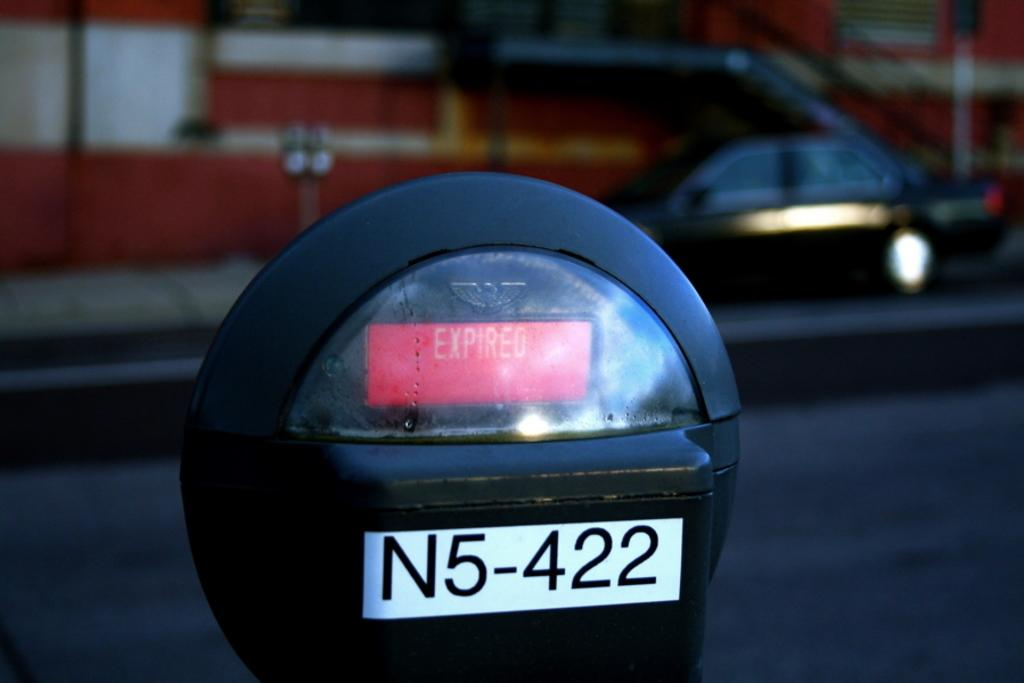Provide a one-sentence caption for the provided image. A digital readout says expired and above a N5-422 label. 